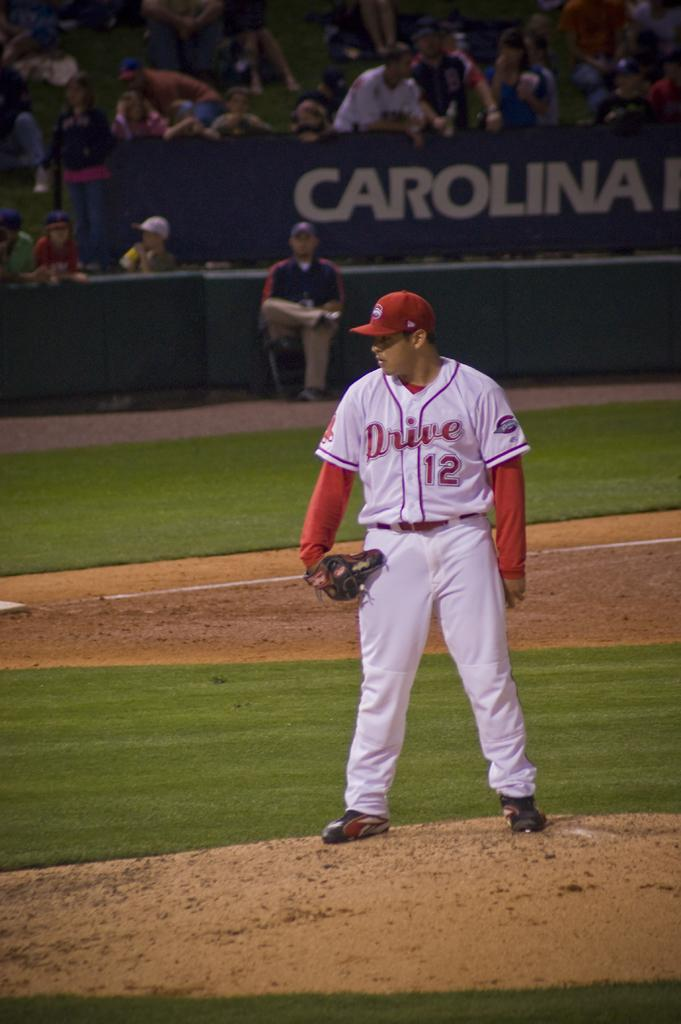<image>
Create a compact narrative representing the image presented. A baseball game is underway in a stadium that says Carolina. 